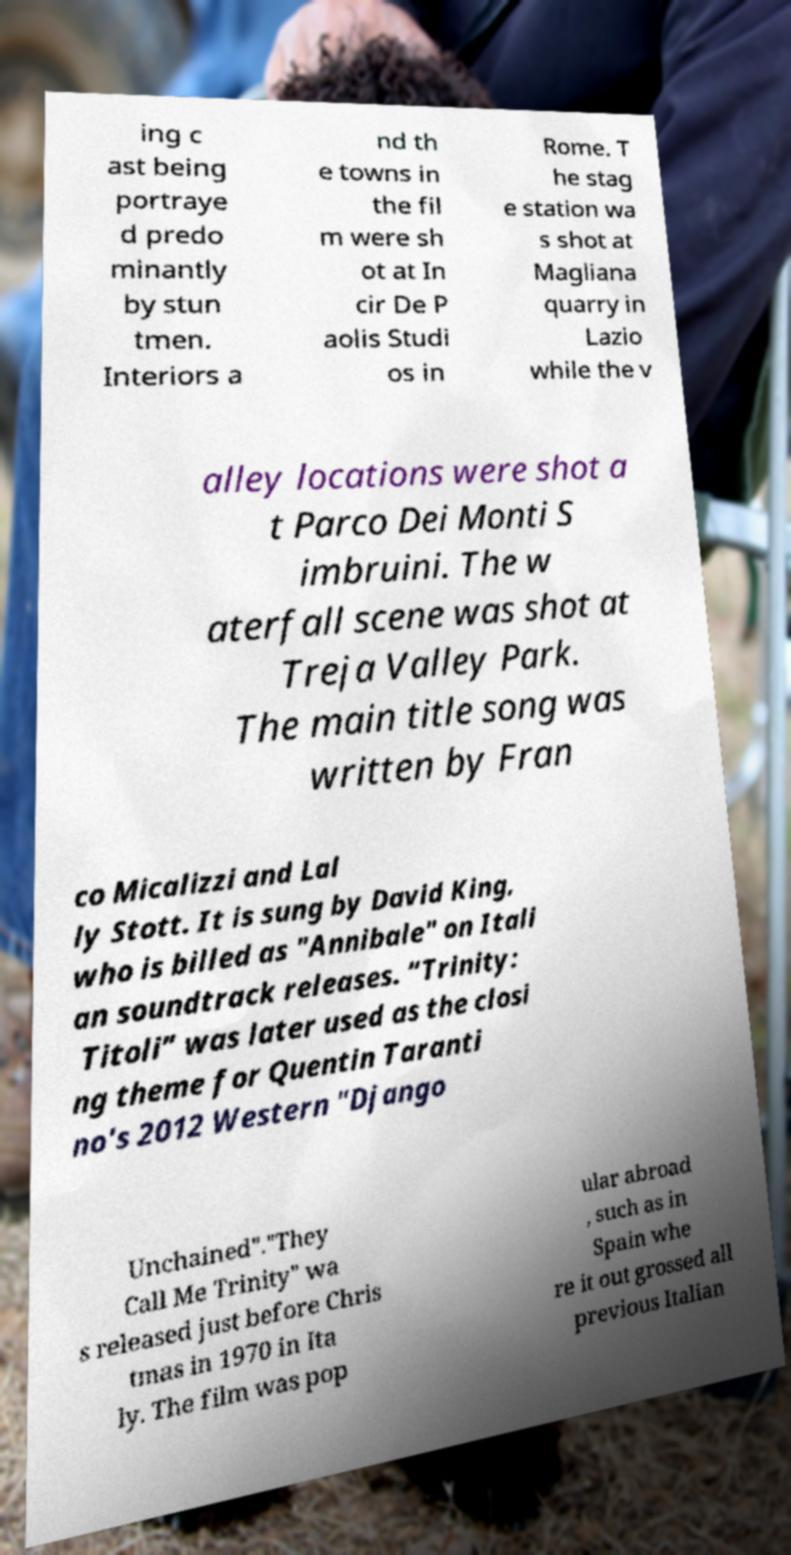What messages or text are displayed in this image? I need them in a readable, typed format. ing c ast being portraye d predo minantly by stun tmen. Interiors a nd th e towns in the fil m were sh ot at In cir De P aolis Studi os in Rome. T he stag e station wa s shot at Magliana quarry in Lazio while the v alley locations were shot a t Parco Dei Monti S imbruini. The w aterfall scene was shot at Treja Valley Park. The main title song was written by Fran co Micalizzi and Lal ly Stott. It is sung by David King, who is billed as "Annibale" on Itali an soundtrack releases. “Trinity: Titoli” was later used as the closi ng theme for Quentin Taranti no's 2012 Western "Django Unchained"."They Call Me Trinity" wa s released just before Chris tmas in 1970 in Ita ly. The film was pop ular abroad , such as in Spain whe re it out grossed all previous Italian 